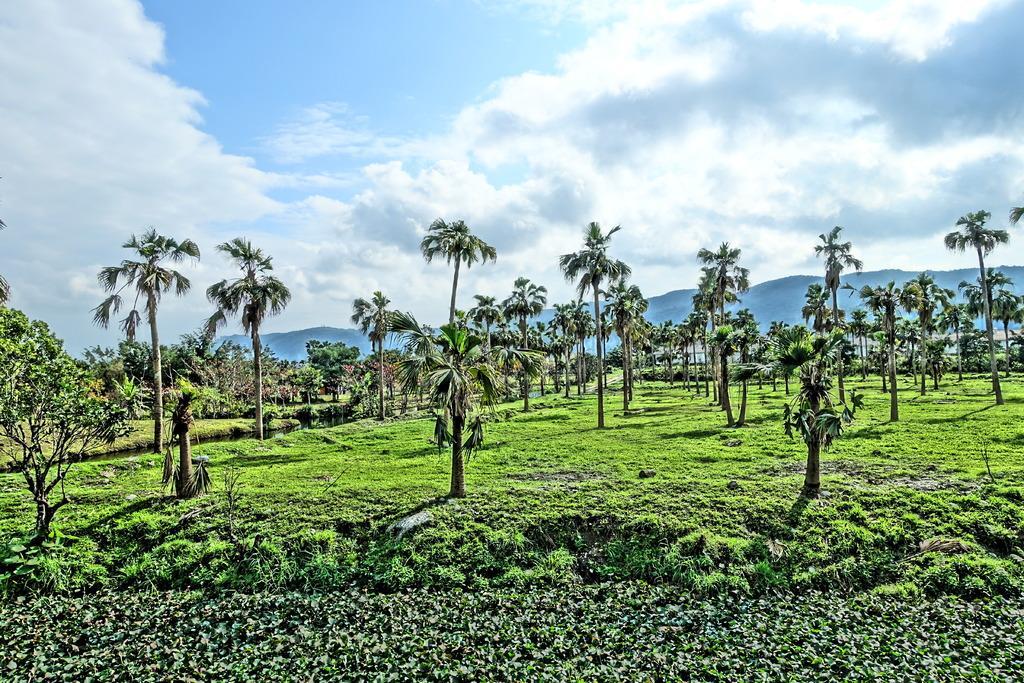Describe this image in one or two sentences. In this image, there are a few trees, plants. We can see the ground with some grass. We can see some hills and the sky with clouds. 